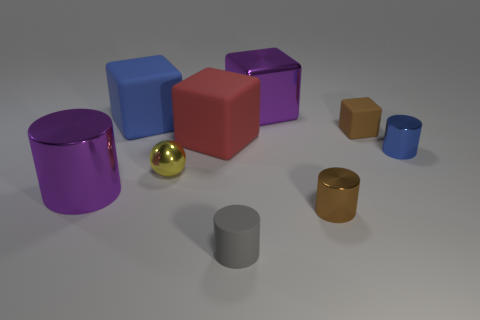Subtract all tiny matte cylinders. How many cylinders are left? 3 Subtract all blue blocks. How many blocks are left? 3 Subtract 1 blocks. How many blocks are left? 3 Subtract 0 yellow cubes. How many objects are left? 9 Subtract all cubes. How many objects are left? 5 Subtract all green blocks. Subtract all green spheres. How many blocks are left? 4 Subtract all blue cylinders. How many brown cubes are left? 1 Subtract all large yellow matte cylinders. Subtract all metallic cylinders. How many objects are left? 6 Add 3 tiny spheres. How many tiny spheres are left? 4 Add 9 tiny purple blocks. How many tiny purple blocks exist? 9 